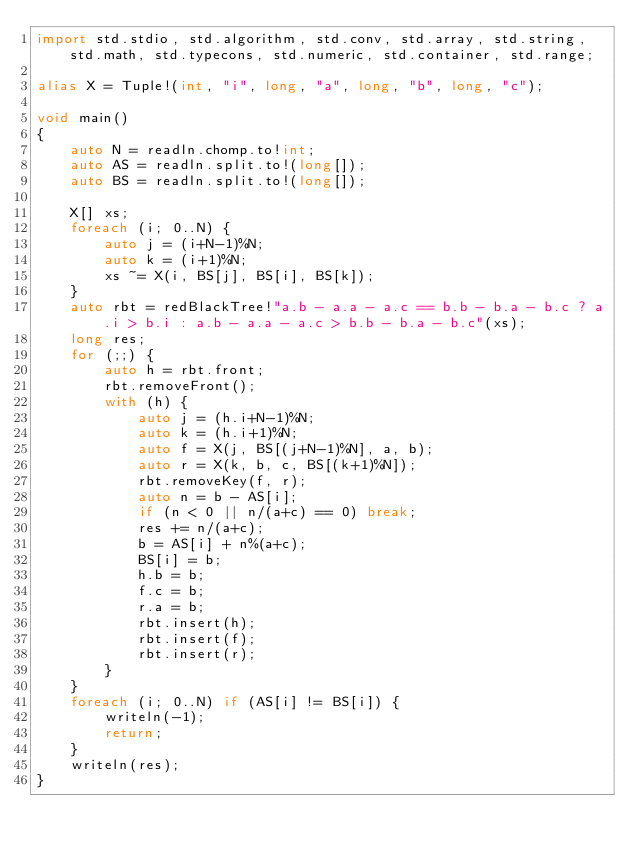<code> <loc_0><loc_0><loc_500><loc_500><_D_>import std.stdio, std.algorithm, std.conv, std.array, std.string, std.math, std.typecons, std.numeric, std.container, std.range;

alias X = Tuple!(int, "i", long, "a", long, "b", long, "c");

void main()
{
    auto N = readln.chomp.to!int;
    auto AS = readln.split.to!(long[]);
    auto BS = readln.split.to!(long[]);

    X[] xs;
    foreach (i; 0..N) {
        auto j = (i+N-1)%N;
        auto k = (i+1)%N;
        xs ~= X(i, BS[j], BS[i], BS[k]);
    }
    auto rbt = redBlackTree!"a.b - a.a - a.c == b.b - b.a - b.c ? a.i > b.i : a.b - a.a - a.c > b.b - b.a - b.c"(xs);
    long res;
    for (;;) {
        auto h = rbt.front;
        rbt.removeFront();
        with (h) {
            auto j = (h.i+N-1)%N;
            auto k = (h.i+1)%N;
            auto f = X(j, BS[(j+N-1)%N], a, b);
            auto r = X(k, b, c, BS[(k+1)%N]);
            rbt.removeKey(f, r);
            auto n = b - AS[i];
            if (n < 0 || n/(a+c) == 0) break;
            res += n/(a+c);
            b = AS[i] + n%(a+c);
            BS[i] = b;
            h.b = b;
            f.c = b;
            r.a = b;
            rbt.insert(h);
            rbt.insert(f);
            rbt.insert(r);
        }
    }
    foreach (i; 0..N) if (AS[i] != BS[i]) {
        writeln(-1);
        return;
    }
    writeln(res);
}</code> 